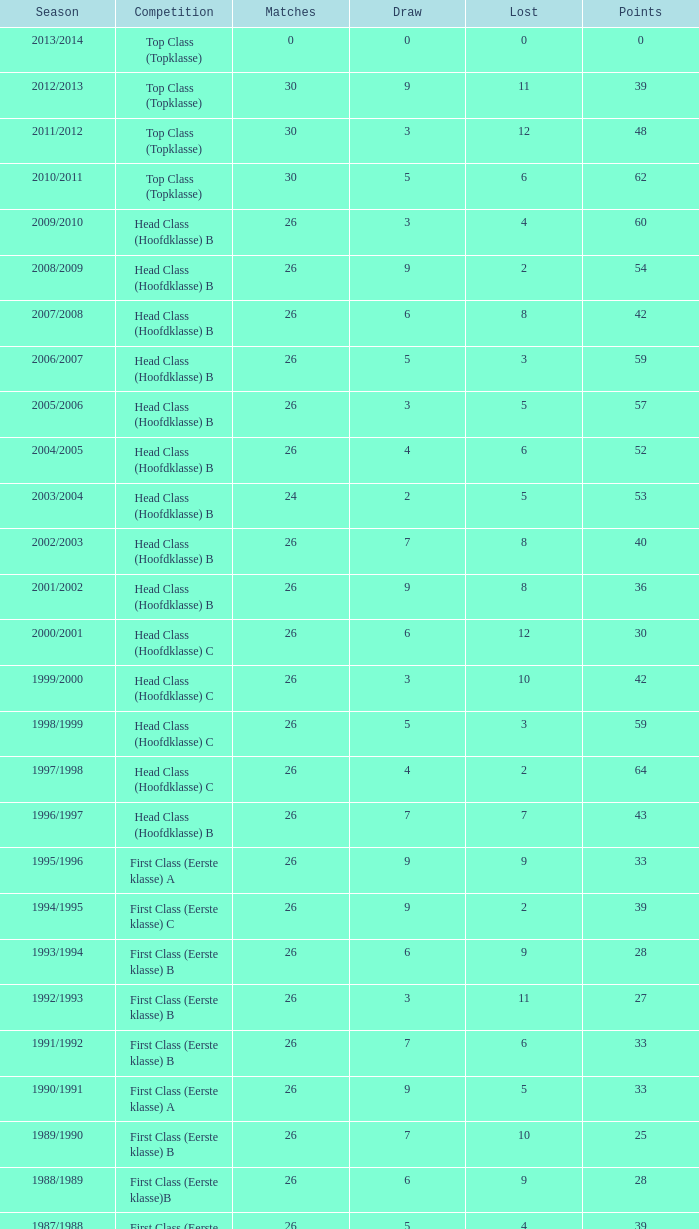How many matches in the 2008/2009 season had less than 5 losses and a draw count greater than 9? 0.0. 